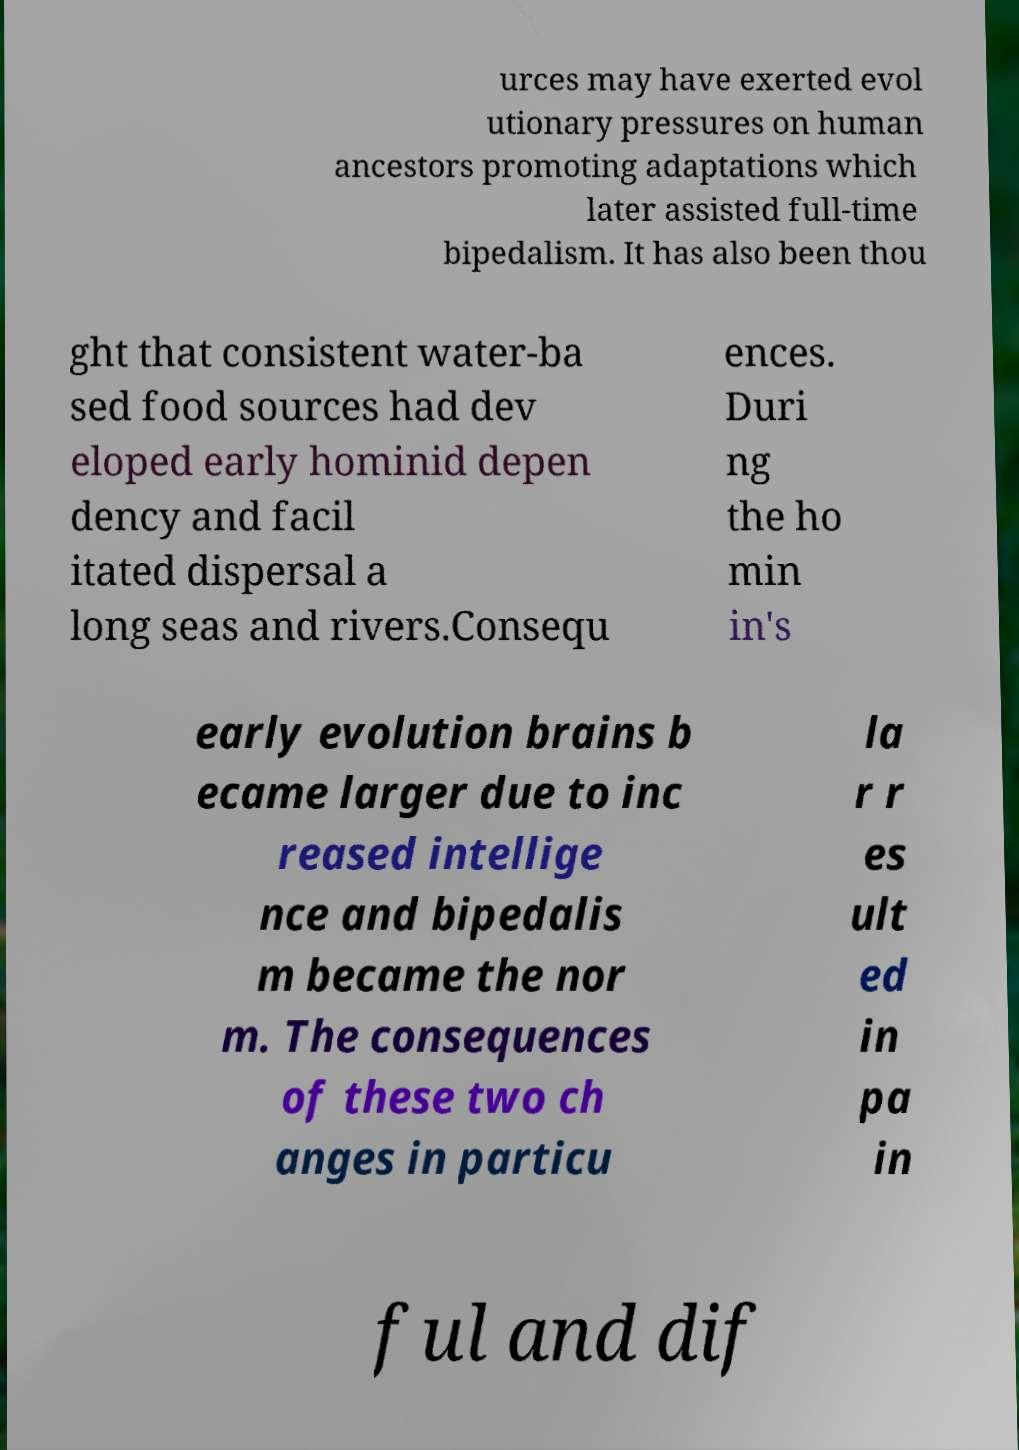For documentation purposes, I need the text within this image transcribed. Could you provide that? urces may have exerted evol utionary pressures on human ancestors promoting adaptations which later assisted full-time bipedalism. It has also been thou ght that consistent water-ba sed food sources had dev eloped early hominid depen dency and facil itated dispersal a long seas and rivers.Consequ ences. Duri ng the ho min in's early evolution brains b ecame larger due to inc reased intellige nce and bipedalis m became the nor m. The consequences of these two ch anges in particu la r r es ult ed in pa in ful and dif 